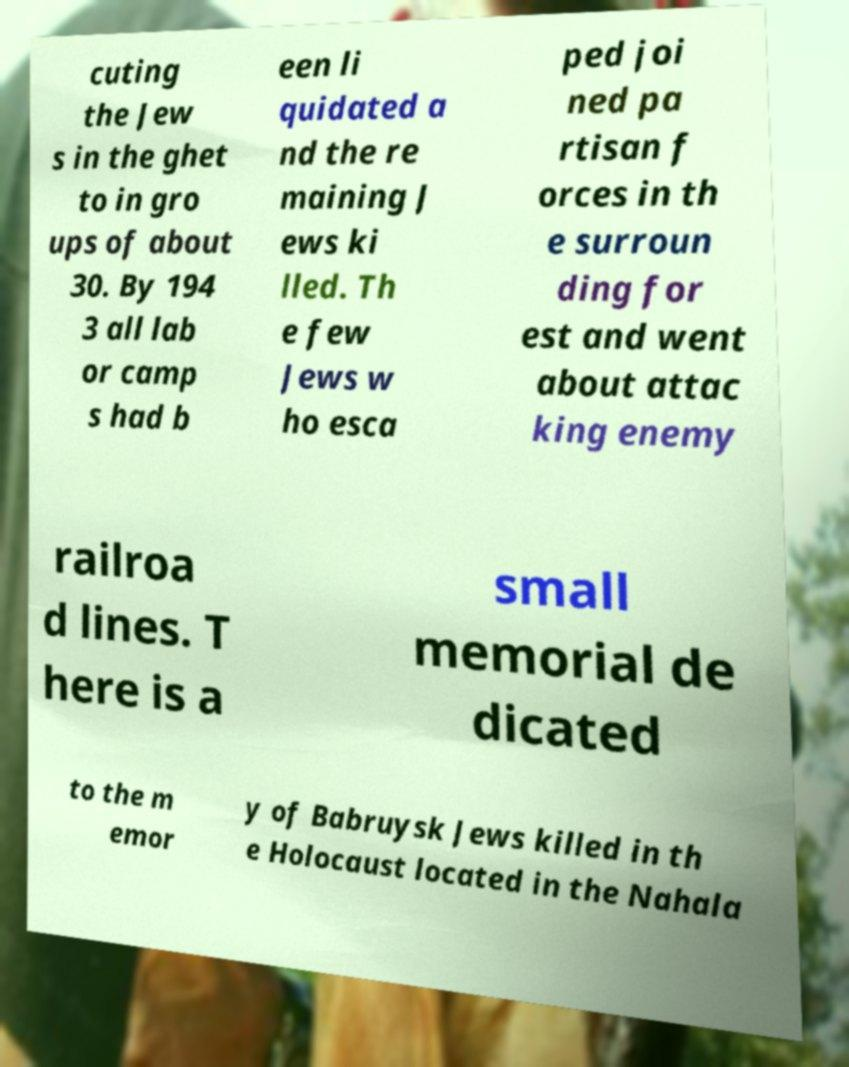What messages or text are displayed in this image? I need them in a readable, typed format. cuting the Jew s in the ghet to in gro ups of about 30. By 194 3 all lab or camp s had b een li quidated a nd the re maining J ews ki lled. Th e few Jews w ho esca ped joi ned pa rtisan f orces in th e surroun ding for est and went about attac king enemy railroa d lines. T here is a small memorial de dicated to the m emor y of Babruysk Jews killed in th e Holocaust located in the Nahala 